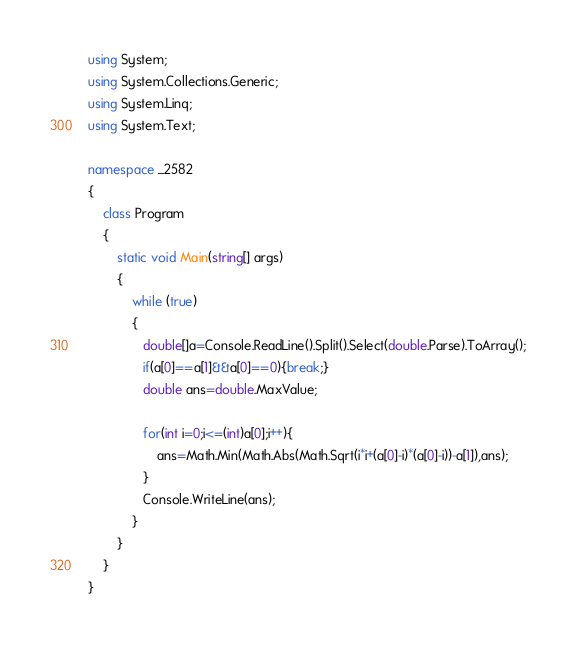<code> <loc_0><loc_0><loc_500><loc_500><_C#_>using System;
using System.Collections.Generic;
using System.Linq;
using System.Text;

namespace _2582
{
    class Program
    {
        static void Main(string[] args)
        {
            while (true)
            {
               double[]a=Console.ReadLine().Split().Select(double.Parse).ToArray();
               if(a[0]==a[1]&&a[0]==0){break;}
               double ans=double.MaxValue;
               
               for(int i=0;i<=(int)a[0];i++){
                   ans=Math.Min(Math.Abs(Math.Sqrt(i*i+(a[0]-i)*(a[0]-i))-a[1]),ans);
               }
               Console.WriteLine(ans);
            }
        }
    }
}</code> 